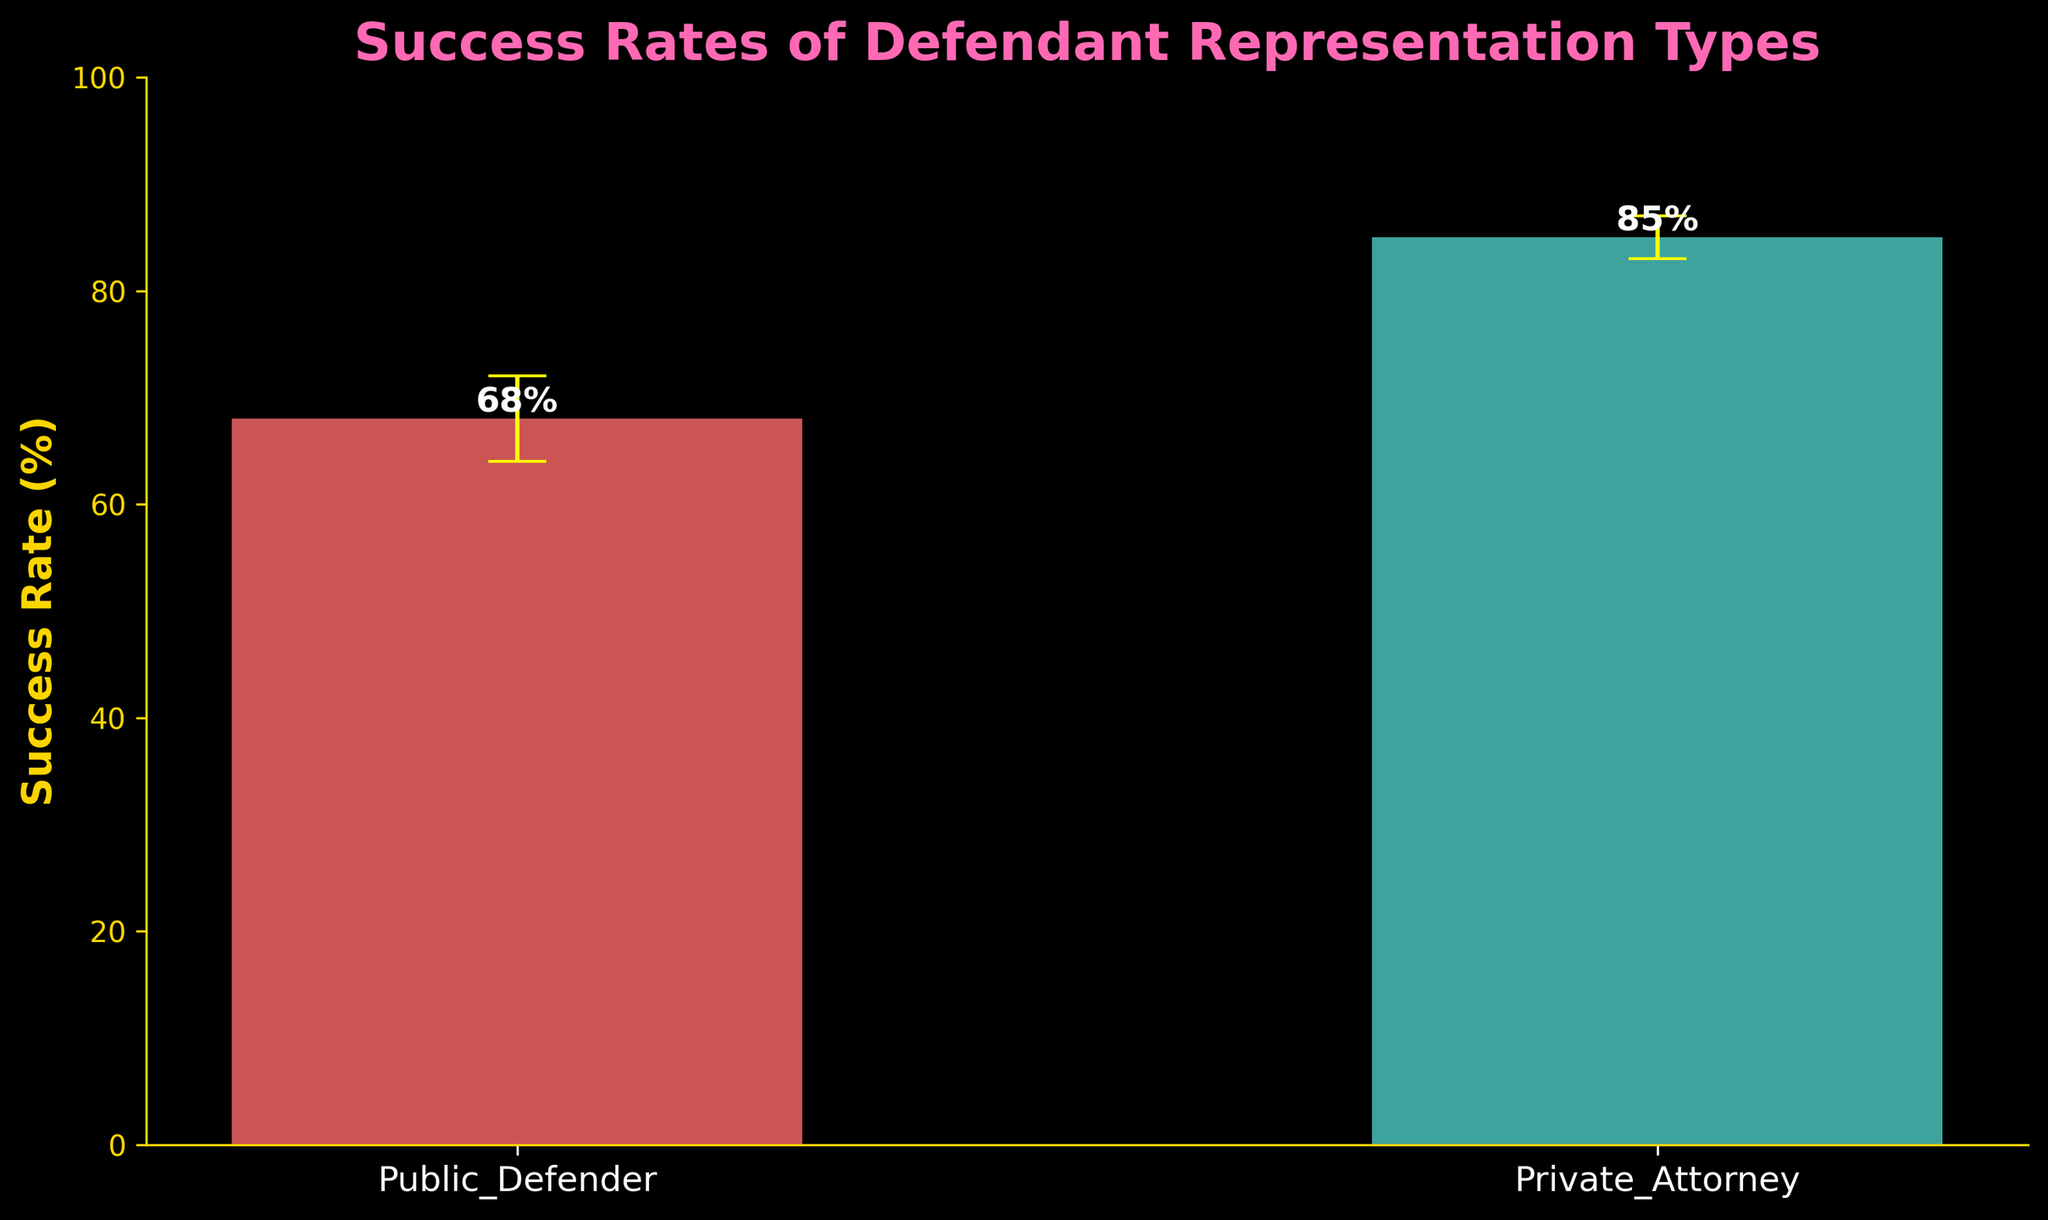What is the title of the figure? The title of the figure is located at the top and it is styled in a bold font with a distinctive color. It provides a summary of the figure's content.
Answer: Success Rates of Defendant Representation Types Which representation type shows a higher success rate? By comparing the heights of the two bars, we can see that the bar for the Private Attorney is higher than the bar for the Public Defender, indicating a higher success rate.
Answer: Private Attorney How high is the success rate for Public Defenders? The figure labels the top of each bar with its value, allowing us to quickly see the exact success rate associated with Public Defenders.
Answer: 68% What are the lower and upper confidence intervals for Private Attorney success rates? The error bars on each bar indicate the confidence intervals. The yellow caps on the Private Attorney bar show its uncertainty range. The confidence intervals can also be deduced from subtracting and adding the provided error margins from the success rate.
Answer: 83% to 87% By how many percentage points does the success rate of Private Attorney exceed that of Public Defender? To find the difference, subtract the success rate of Public Defender from that of Private Attorney: 85% - 68% = 17%.
Answer: 17 percentage points Which representation type has wider confidence intervals? To determine the interval width, subtract the lower confidence interval from the upper for each type. Public Defender: 72% - 64% = 8%. Private Attorney: 87% - 83% = 4%. Compare these values to identify the wider interval.
Answer: Public Defender What is the average success rate between the two representation types? Add the two success rates together and divide by 2: (68% + 85%) / 2 = 76.5%.
Answer: 76.5% Explain the significance of the yellow caps on the error bars. The yellow caps represent the endpoints of the confidence intervals, indicating the range within which the true success rates are likely to fall. These intervals provide insight into the uncertainty associated with the measured success rates.
Answer: They show the confidence intervals 